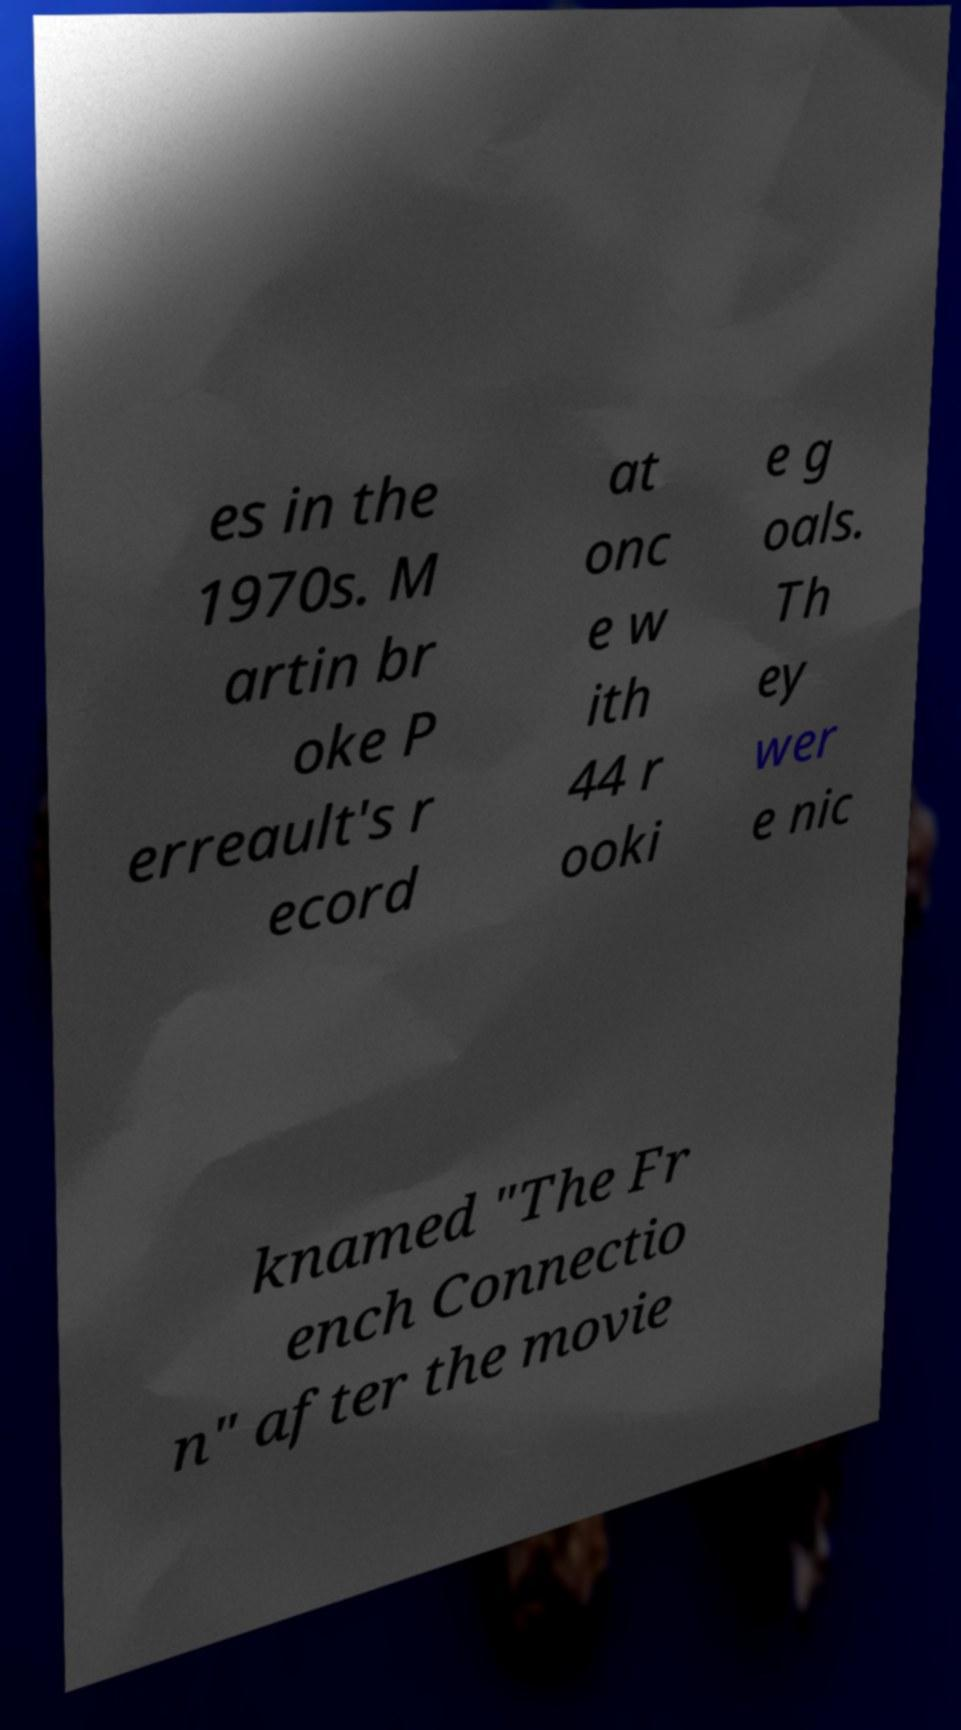Can you read and provide the text displayed in the image?This photo seems to have some interesting text. Can you extract and type it out for me? es in the 1970s. M artin br oke P erreault's r ecord at onc e w ith 44 r ooki e g oals. Th ey wer e nic knamed "The Fr ench Connectio n" after the movie 